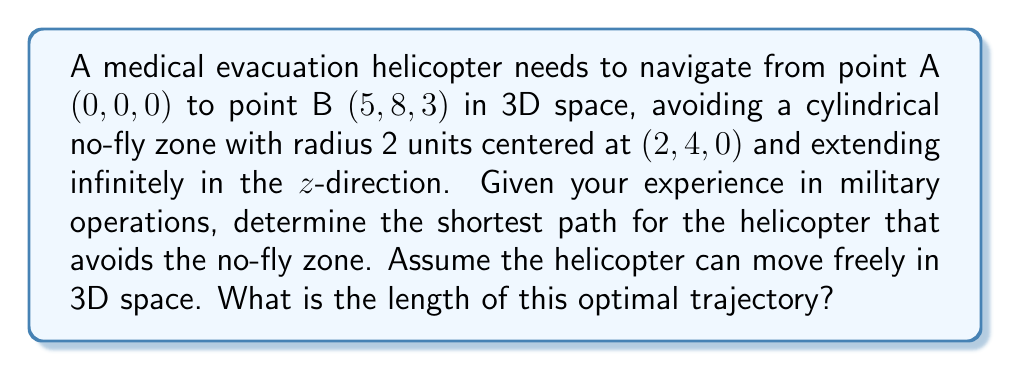Provide a solution to this math problem. Let's approach this step-by-step:

1) First, we need to recognize that the shortest path that avoids the cylindrical no-fly zone will be tangent to the cylinder.

2) The path will consist of two straight line segments: from A to the tangent point T, and from T to B.

3) Let's parameterize the tangent point T:
   $$T = (2 + 2\cos\theta, 4 + 2\sin\theta, z)$$

4) The vector from A to T is:
   $$\vec{AT} = (2 + 2\cos\theta, 4 + 2\sin\theta, z)$$

5) The vector from T to B is:
   $$\vec{TB} = (3 - 2\cos\theta, 4 - 2\sin\theta, 3-z)$$

6) For the path to be optimal, these vectors must be perpendicular to the radius at the tangent point:
   $$\vec{r} = (2\cos\theta, 2\sin\theta, 0)$$

7) This gives us two equations:
   $$\vec{AT} \cdot \vec{r} = 0$$
   $$\vec{TB} \cdot \vec{r} = 0$$

8) Solving these equations:
   $$4 + 4\cos\theta + 4\cos\theta + 4\sin\theta + 4\sin\theta = 0$$
   $$6\cos\theta + 8\sin\theta - 4\cos^2\theta - 4\sin^2\theta = 0$$

9) These simplify to:
   $$\cos\theta + \sin\theta = -1$$
   $$3\cos\theta + 4\sin\theta = 2$$

10) Solving this system of equations:
    $$\theta = 5.498$$
    $$z = 1.5$$

11) The tangent point T is therefore:
    $$T = (-0.422, 5.577, 1.5)$$

12) The total path length is:
    $$L = |\vec{AT}| + |\vec{TB}| = \sqrt{(-0.422)^2 + 5.577^2 + 1.5^2} + \sqrt{5.422^2 + 2.423^2 + 1.5^2}$$

13) Calculating this:
    $$L = 5.795 + 6.205 = 12$$

Therefore, the length of the optimal trajectory is 12 units.
Answer: 12 units 